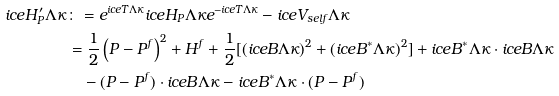Convert formula to latex. <formula><loc_0><loc_0><loc_500><loc_500>\sl i c e { H ^ { \prime } _ { P } } { \Lambda } { \kappa } & \colon = e ^ { \sl i c e { T } { \Lambda } { \kappa } } \sl i c e { H _ { P } } { \Lambda } { \kappa } e ^ { - \sl i c e { T } { \Lambda } { \kappa } } - \sl i c e { V _ { s e l f } } { \Lambda } { \kappa } \\ & = \frac { 1 } { 2 } \left ( P - P ^ { f } \right ) ^ { 2 } + H ^ { f } + \frac { 1 } { 2 } [ ( \sl i c e { B } { \Lambda } { \kappa } ) ^ { 2 } + ( \sl i c e { B ^ { * } } { \Lambda } { \kappa } ) ^ { 2 } ] + \sl i c e { B ^ { * } } { \Lambda } { \kappa } \cdot \sl i c e { B } { \Lambda } { \kappa } \\ & \quad - ( P - P ^ { f } ) \cdot \sl i c e { B } { \Lambda } { \kappa } - \sl i c e { B ^ { * } } { \Lambda } { \kappa } \cdot ( P - P ^ { f } )</formula> 